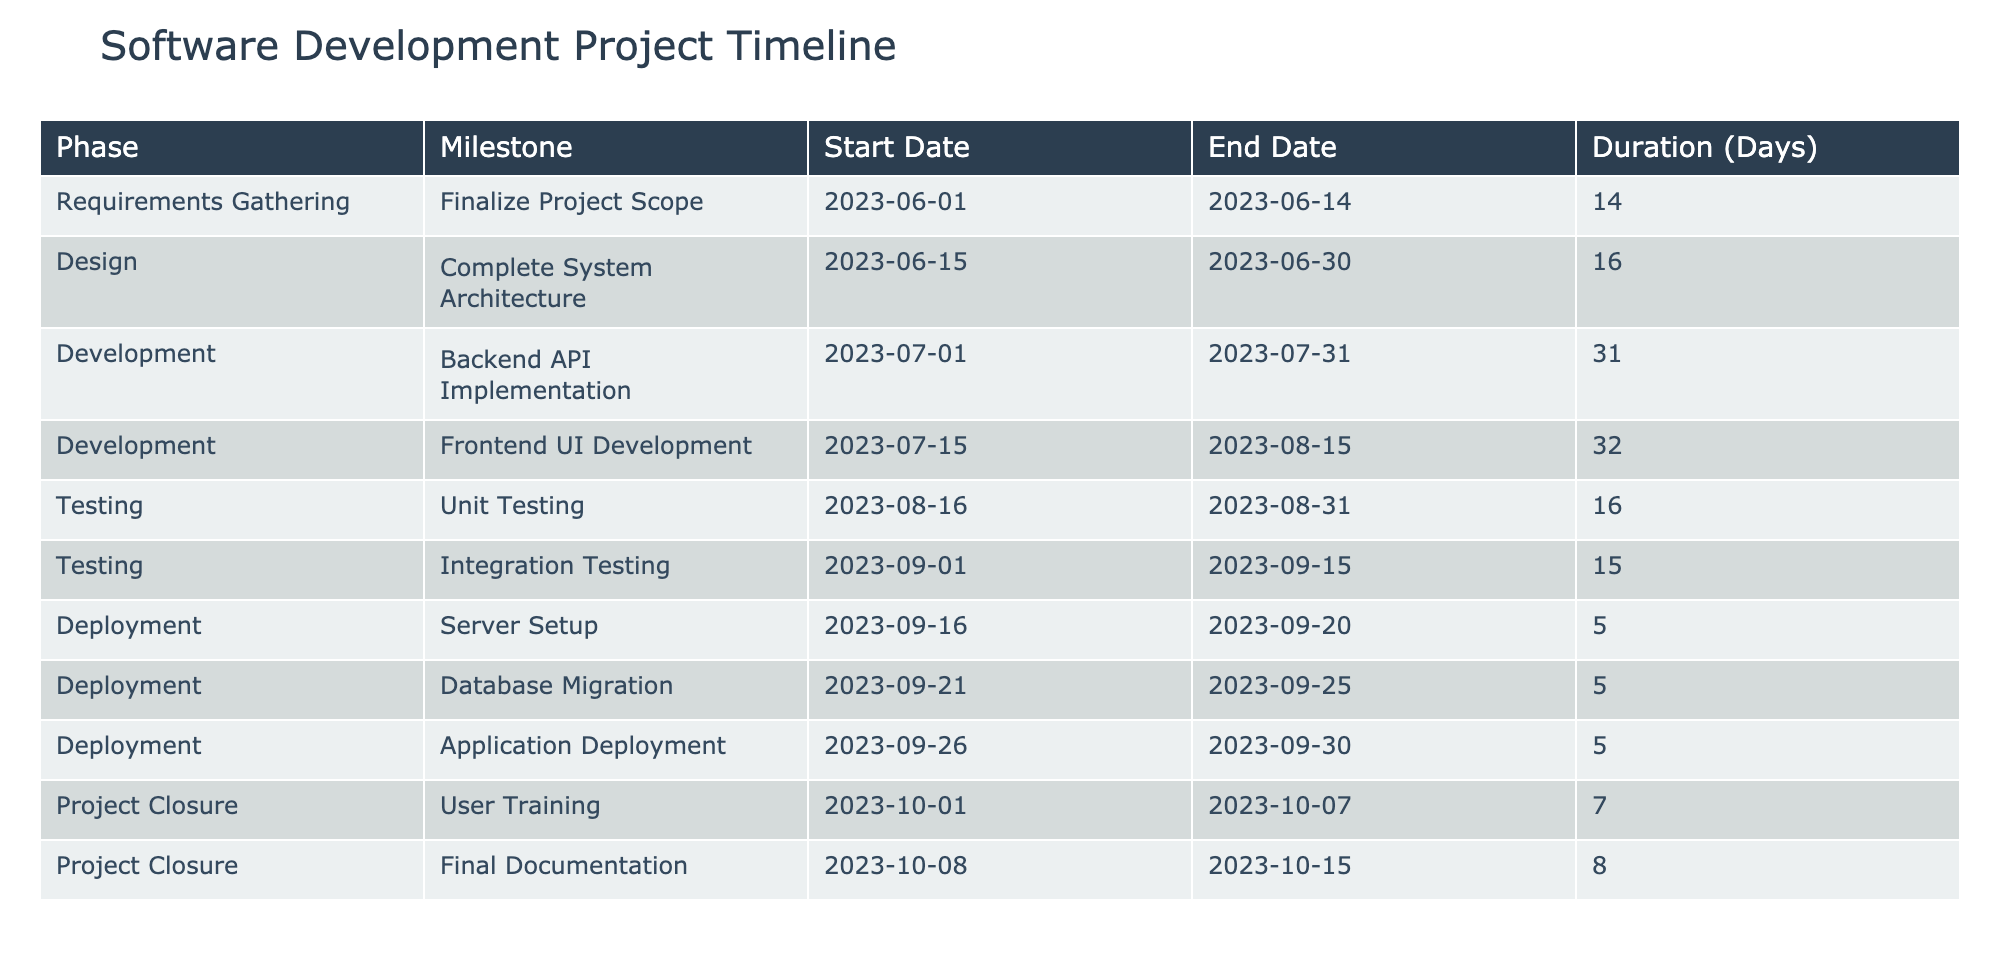What is the duration of the "Backend API Implementation" milestone? The duration can be found in the "Duration (Days)" column corresponding to the "Backend API Implementation" milestone in the table, which is 31 days.
Answer: 31 days What is the earliest start date for any milestone in the project? By examining the "Start Date" column, the earliest date listed is 2023-06-01, which corresponds to the "Finalize Project Scope" milestone.
Answer: 2023-06-01 How many days in total are allocated for development activities? The development phase includes "Backend API Implementation" (31 days) and "Frontend UI Development" (32 days). Summing these gives 31 + 32 = 63 days for development activities.
Answer: 63 days Did the "User Training" milestone start after the "Server Setup" milestone? Checking the "Start Date" for "User Training" (2023-10-01) and for "Server Setup" (2023-09-16), we see that 2023-10-01 is indeed after 2023-09-16. Thus, the statement is true.
Answer: Yes What is the total duration of the "Testing" phase milestones? The "Testing" phase includes "Unit Testing" (16 days) and "Integration Testing" (15 days). Adding these gives 16 + 15 = 31 days for the entire phase.
Answer: 31 days Which milestone has the longest duration in the project? Looking through the "Duration (Days)" column, "Frontend UI Development" is 32 days, which is the longest compared to other durations listed in the table.
Answer: Frontend UI Development Was the "Application Deployment" milestone completed before "Final Documentation"? By examining the "End Date" for "Application Deployment" (2023-09-30) and "Final Documentation" (2023-10-15), it's clear that 2023-09-30 comes before 2023-10-15. Thus, the statement is true.
Answer: Yes What is the average duration of all milestones in the project? The total number of days for all milestones can be calculated: 14 + 16 + 31 + 32 + 16 + 15 + 5 + 5 + 5 + 7 + 8 =  234 days. There are 11 milestones, so the average is 234 / 11 = 21.27 days.
Answer: 21.27 days How many milestones are part of the "Deployment" phase? The "Deployment" phase has three milestones listed: "Server Setup," "Database Migration," and "Application Deployment," which totals to 3 milestones in this phase.
Answer: 3 milestones 